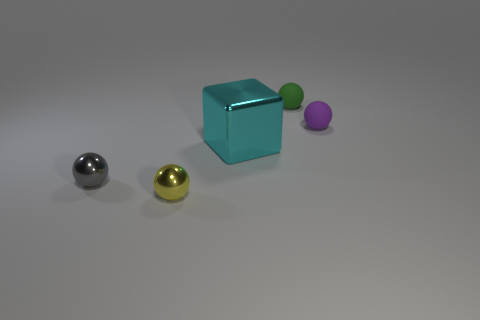What is the material of the tiny green object?
Provide a succinct answer. Rubber. There is a tiny object that is behind the matte thing that is in front of the tiny ball that is behind the purple rubber sphere; what shape is it?
Your answer should be very brief. Sphere. How many other things are the same shape as the small green thing?
Ensure brevity in your answer.  3. Is the color of the block the same as the tiny matte thing that is to the left of the purple sphere?
Your answer should be compact. No. How many big red metal blocks are there?
Offer a terse response. 0. How many objects are either large green metallic cylinders or matte things?
Your response must be concise. 2. Are there any cyan metallic blocks behind the large shiny block?
Provide a succinct answer. No. Is the number of tiny yellow things that are behind the purple rubber thing greater than the number of yellow balls that are in front of the yellow ball?
Keep it short and to the point. No. There is a gray metal object that is the same shape as the green rubber thing; what is its size?
Ensure brevity in your answer.  Small. How many spheres are either tiny yellow metallic things or tiny gray metallic things?
Your answer should be compact. 2. 